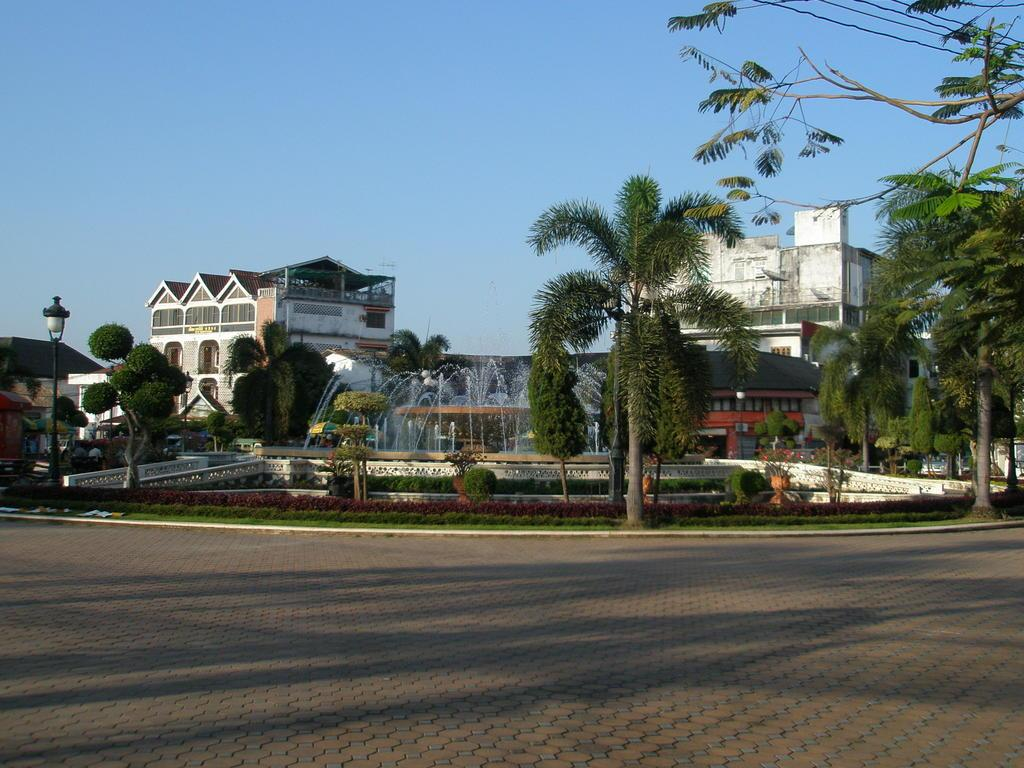What can be seen on the ground in the image? There are shadows of objects on the path in the image. What provides illumination in the image? Street lights are visible in the image. What type of vegetation is present in the image? Plants and trees are visible in the image. What type of water feature can be seen in the image? Fountains are present in the image. What type of barrier is present in the image? There is some fencing in the image. What type of structures are visible in the image? Buildings are visible in the image. What else can be seen in the image besides the mentioned elements? Other objects are present in the image. What is visible in the sky in the image? The sky is visible in the image. How many ants can be seen carrying cherries on the path in the image? There are no ants or cherries present in the image. What is the weight of the cherry tree in the image? There is no cherry tree present in the image, so it is not possible to determine its weight. 